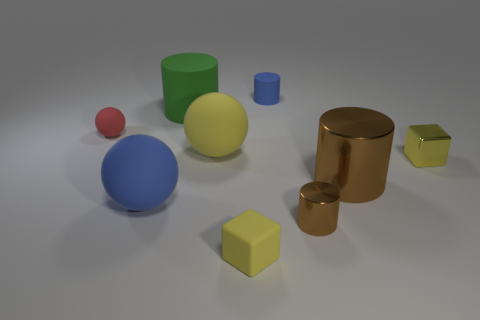Subtract all small blue cylinders. How many cylinders are left? 3 Subtract all brown balls. How many brown cylinders are left? 2 Subtract 2 cylinders. How many cylinders are left? 2 Subtract all green cylinders. How many cylinders are left? 3 Subtract all cylinders. How many objects are left? 5 Add 1 small shiny cylinders. How many objects exist? 10 Subtract all yellow cylinders. Subtract all brown blocks. How many cylinders are left? 4 Add 2 tiny yellow rubber things. How many tiny yellow rubber things are left? 3 Add 5 rubber cylinders. How many rubber cylinders exist? 7 Subtract 2 brown cylinders. How many objects are left? 7 